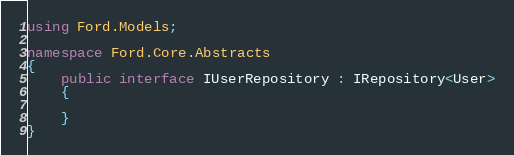Convert code to text. <code><loc_0><loc_0><loc_500><loc_500><_C#_>using Ford.Models;

namespace Ford.Core.Abstracts
{
    public interface IUserRepository : IRepository<User>
    {
        
    }
}</code> 